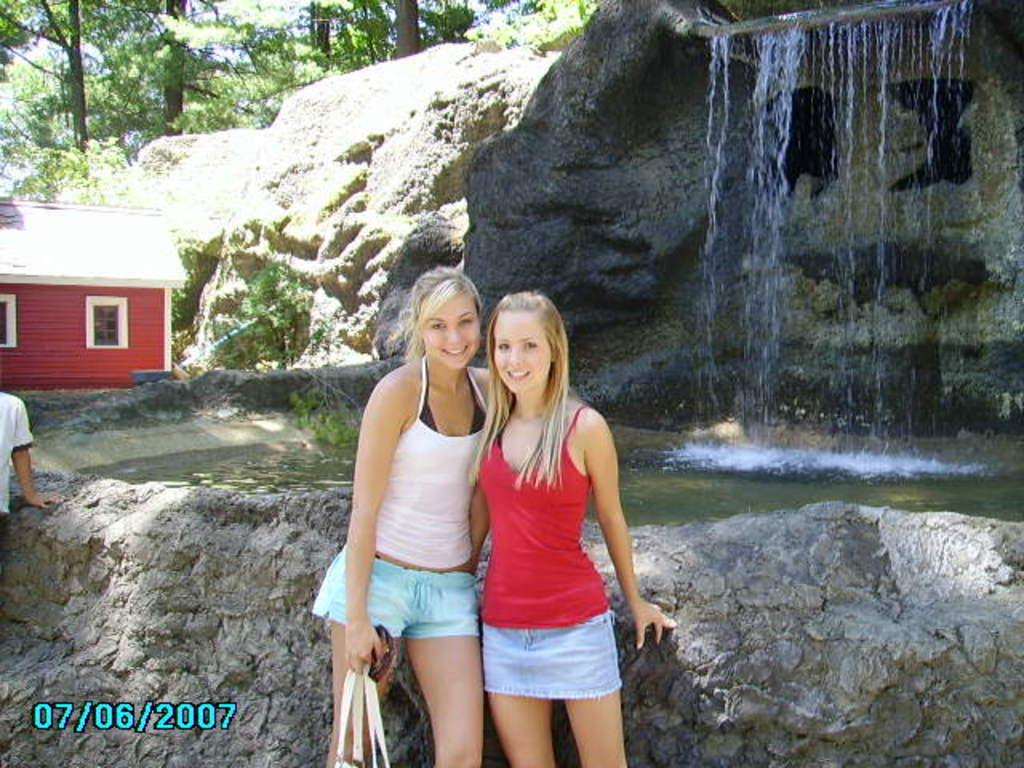Provide a one-sentence caption for the provided image. A few older girls are posing for the camera in front of a waterfall, with the photo being dated 07/06/2007. 